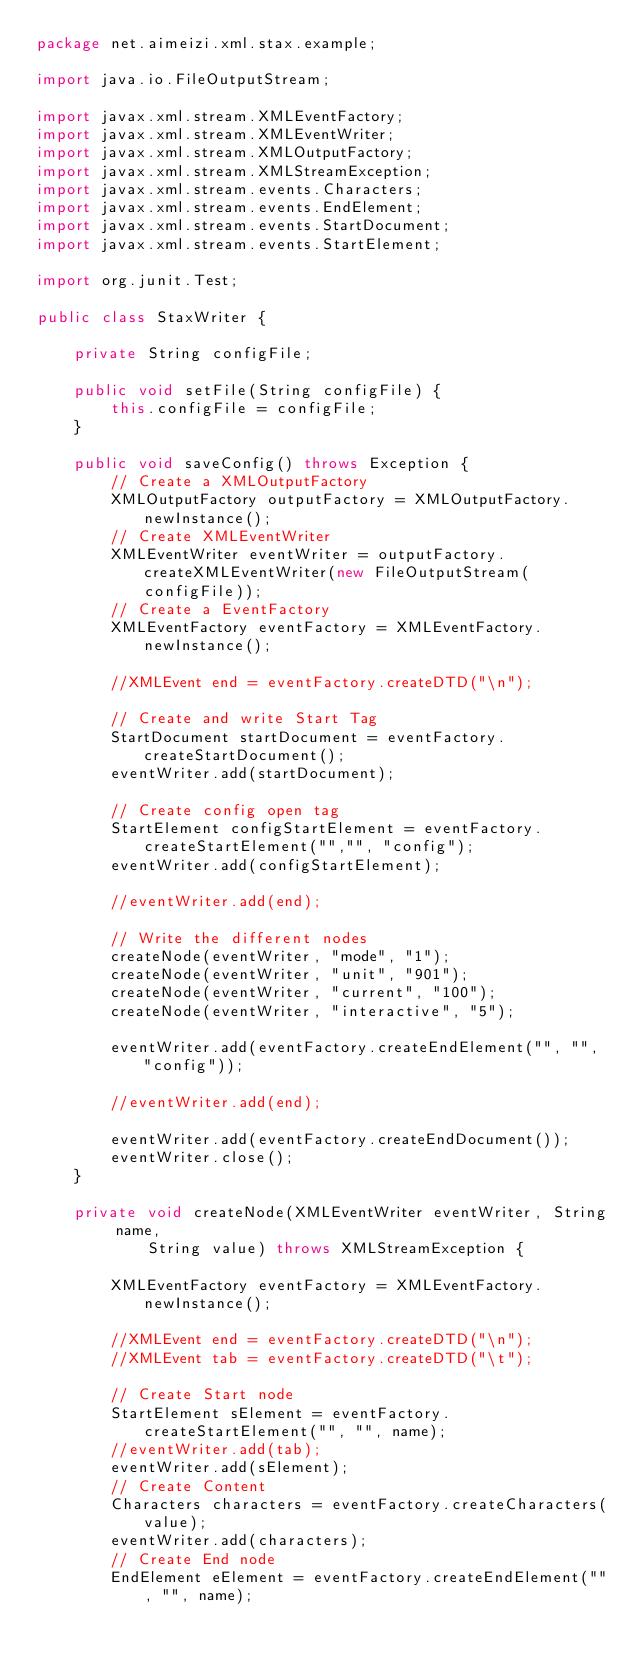Convert code to text. <code><loc_0><loc_0><loc_500><loc_500><_Java_>package net.aimeizi.xml.stax.example;

import java.io.FileOutputStream;

import javax.xml.stream.XMLEventFactory;
import javax.xml.stream.XMLEventWriter;
import javax.xml.stream.XMLOutputFactory;
import javax.xml.stream.XMLStreamException;
import javax.xml.stream.events.Characters;
import javax.xml.stream.events.EndElement;
import javax.xml.stream.events.StartDocument;
import javax.xml.stream.events.StartElement;

import org.junit.Test;

public class StaxWriter {

	private String configFile;

	public void setFile(String configFile) {
		this.configFile = configFile;
	}

	public void saveConfig() throws Exception {
		// Create a XMLOutputFactory
		XMLOutputFactory outputFactory = XMLOutputFactory.newInstance();
		// Create XMLEventWriter
		XMLEventWriter eventWriter = outputFactory.createXMLEventWriter(new FileOutputStream(configFile));
		// Create a EventFactory
		XMLEventFactory eventFactory = XMLEventFactory.newInstance();
		
		//XMLEvent end = eventFactory.createDTD("\n");
		
		// Create and write Start Tag
		StartDocument startDocument = eventFactory.createStartDocument();
		eventWriter.add(startDocument);

		// Create config open tag
		StartElement configStartElement = eventFactory.createStartElement("","", "config");
		eventWriter.add(configStartElement);
		
		//eventWriter.add(end);
		
		// Write the different nodes
		createNode(eventWriter, "mode", "1");
		createNode(eventWriter, "unit", "901");
		createNode(eventWriter, "current", "100");
		createNode(eventWriter, "interactive", "5");

		eventWriter.add(eventFactory.createEndElement("", "", "config"));
		
		//eventWriter.add(end);
		
		eventWriter.add(eventFactory.createEndDocument());
		eventWriter.close();
	}

	private void createNode(XMLEventWriter eventWriter, String name,
			String value) throws XMLStreamException {

		XMLEventFactory eventFactory = XMLEventFactory.newInstance();
		
		//XMLEvent end = eventFactory.createDTD("\n");
		//XMLEvent tab = eventFactory.createDTD("\t");
		
		// Create Start node
		StartElement sElement = eventFactory.createStartElement("", "", name);
		//eventWriter.add(tab);
		eventWriter.add(sElement);
		// Create Content
		Characters characters = eventFactory.createCharacters(value);
		eventWriter.add(characters);
		// Create End node
		EndElement eElement = eventFactory.createEndElement("", "", name);</code> 